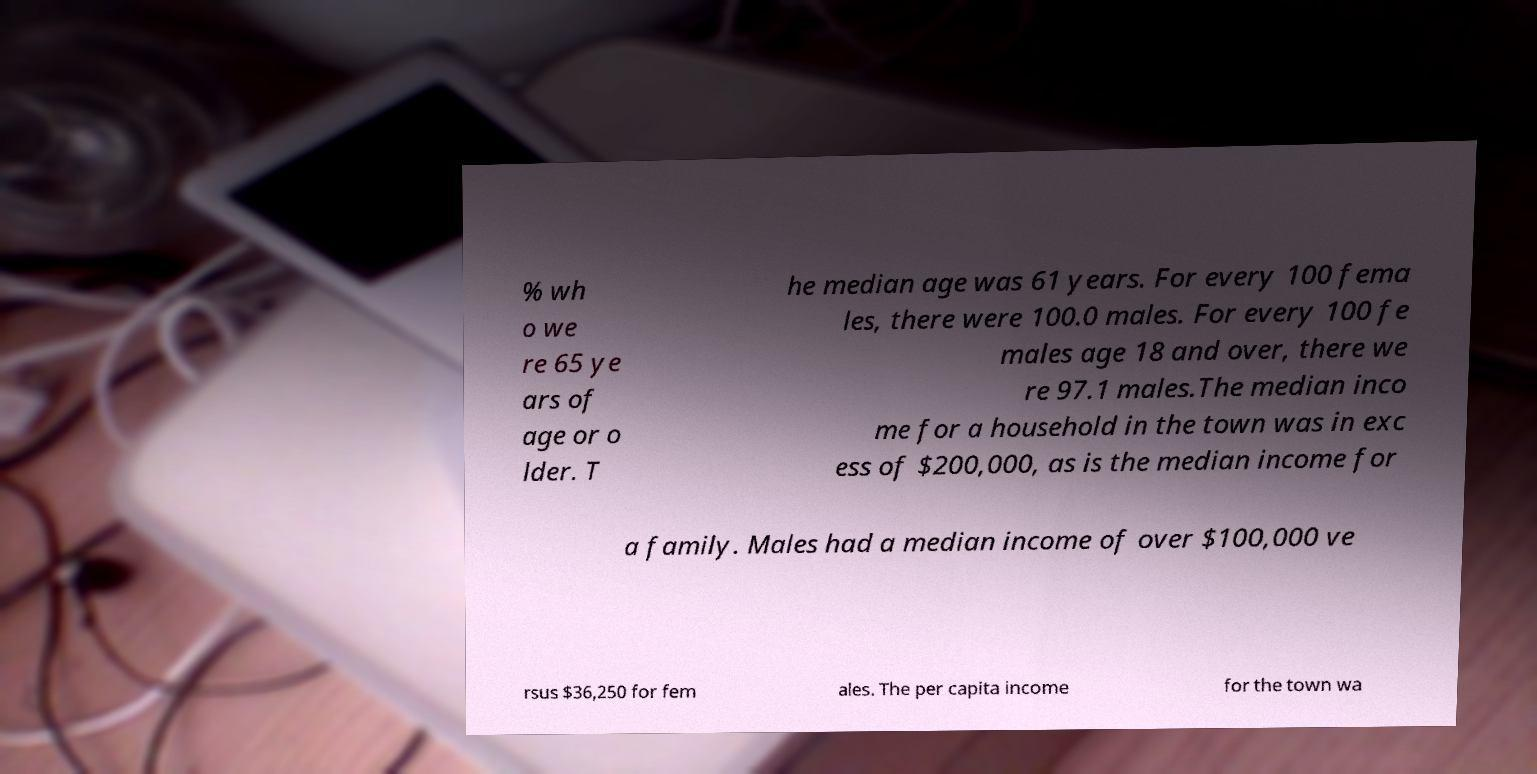I need the written content from this picture converted into text. Can you do that? % wh o we re 65 ye ars of age or o lder. T he median age was 61 years. For every 100 fema les, there were 100.0 males. For every 100 fe males age 18 and over, there we re 97.1 males.The median inco me for a household in the town was in exc ess of $200,000, as is the median income for a family. Males had a median income of over $100,000 ve rsus $36,250 for fem ales. The per capita income for the town wa 